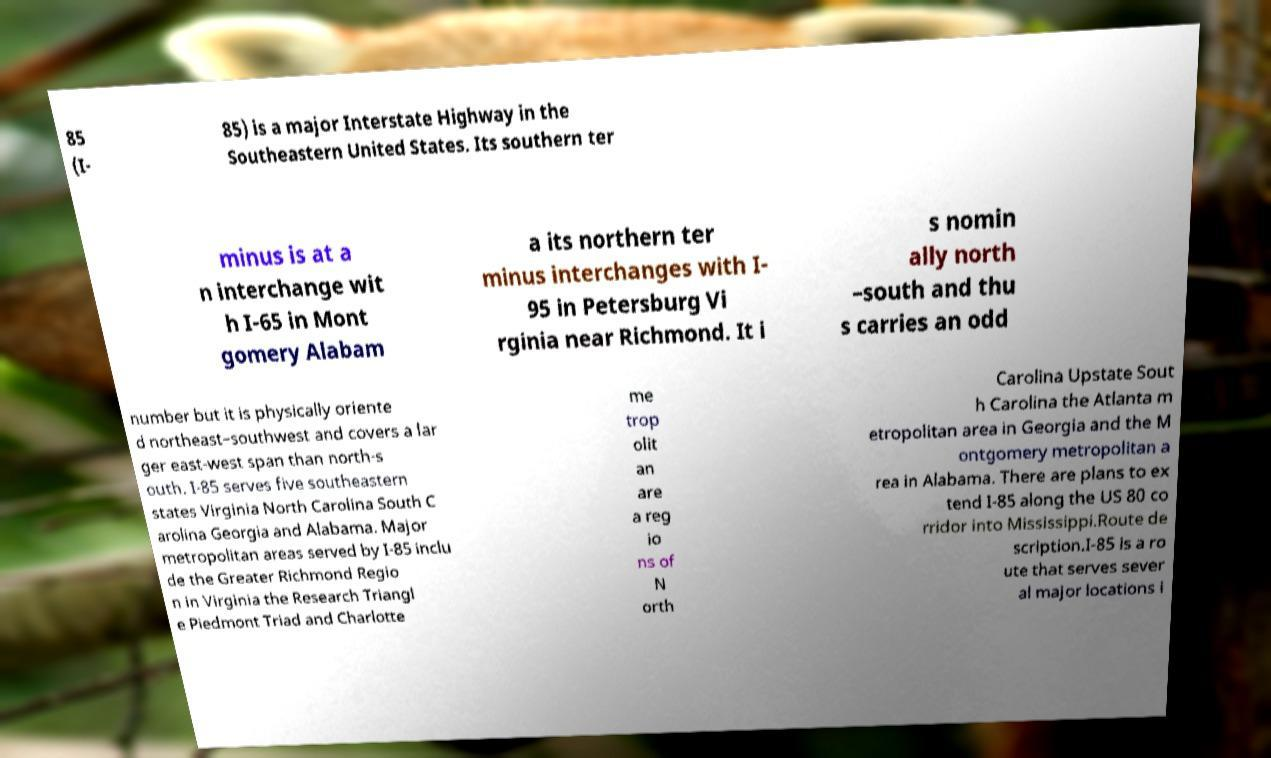There's text embedded in this image that I need extracted. Can you transcribe it verbatim? 85 (I- 85) is a major Interstate Highway in the Southeastern United States. Its southern ter minus is at a n interchange wit h I-65 in Mont gomery Alabam a its northern ter minus interchanges with I- 95 in Petersburg Vi rginia near Richmond. It i s nomin ally north –south and thu s carries an odd number but it is physically oriente d northeast–southwest and covers a lar ger east-west span than north-s outh. I-85 serves five southeastern states Virginia North Carolina South C arolina Georgia and Alabama. Major metropolitan areas served by I-85 inclu de the Greater Richmond Regio n in Virginia the Research Triangl e Piedmont Triad and Charlotte me trop olit an are a reg io ns of N orth Carolina Upstate Sout h Carolina the Atlanta m etropolitan area in Georgia and the M ontgomery metropolitan a rea in Alabama. There are plans to ex tend I-85 along the US 80 co rridor into Mississippi.Route de scription.I-85 is a ro ute that serves sever al major locations i 